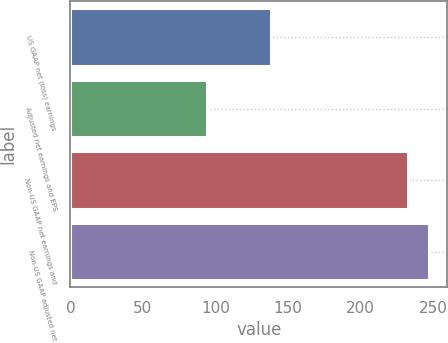Convert chart to OTSL. <chart><loc_0><loc_0><loc_500><loc_500><bar_chart><fcel>US GAAP net (loss) earnings<fcel>Adjusted net earnings and EPS<fcel>Non-US GAAP net earnings and<fcel>Non-US GAAP adjusted net<nl><fcel>138.5<fcel>94.3<fcel>232.8<fcel>247.71<nl></chart> 